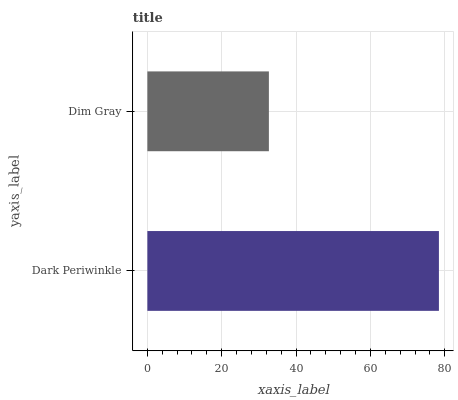Is Dim Gray the minimum?
Answer yes or no. Yes. Is Dark Periwinkle the maximum?
Answer yes or no. Yes. Is Dim Gray the maximum?
Answer yes or no. No. Is Dark Periwinkle greater than Dim Gray?
Answer yes or no. Yes. Is Dim Gray less than Dark Periwinkle?
Answer yes or no. Yes. Is Dim Gray greater than Dark Periwinkle?
Answer yes or no. No. Is Dark Periwinkle less than Dim Gray?
Answer yes or no. No. Is Dark Periwinkle the high median?
Answer yes or no. Yes. Is Dim Gray the low median?
Answer yes or no. Yes. Is Dim Gray the high median?
Answer yes or no. No. Is Dark Periwinkle the low median?
Answer yes or no. No. 